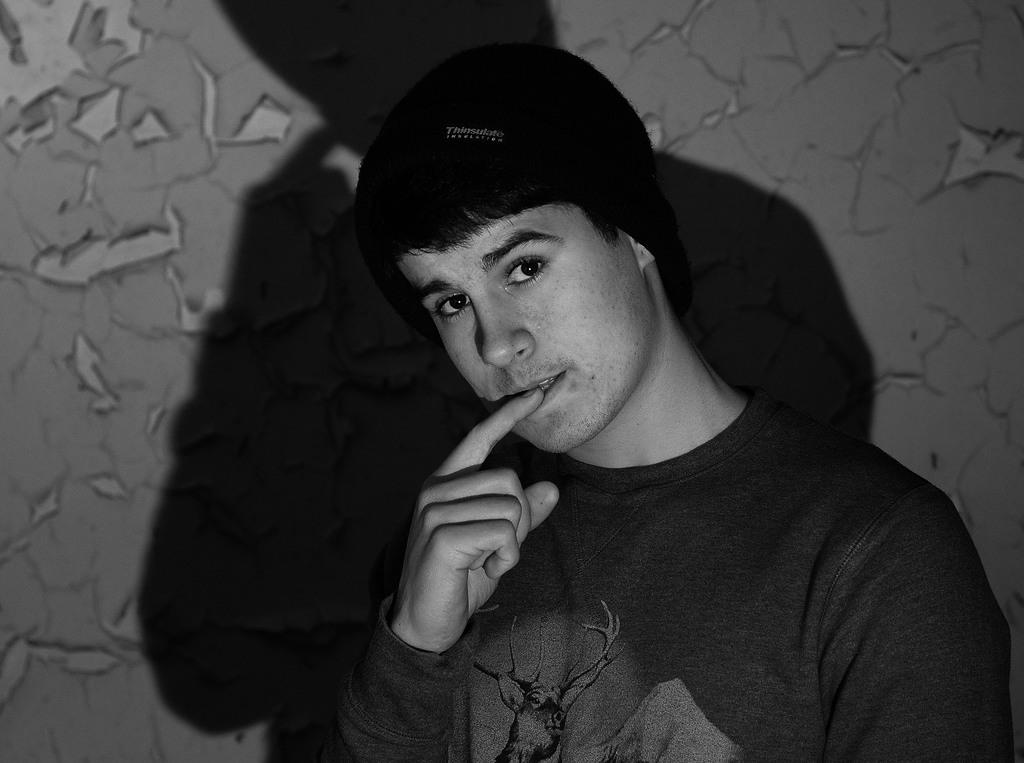What is the color scheme of the image? The image is black and white. Who is present in the image? There is a man in the image. What is the man doing in the image? The man is looking forward. Can you describe any additional features in the image? There is a shadow of the man on the wall in the image. What is the man's tendency to win the competition in the image? There is no competition present in the image, so it is not possible to determine the man's tendency to win. 